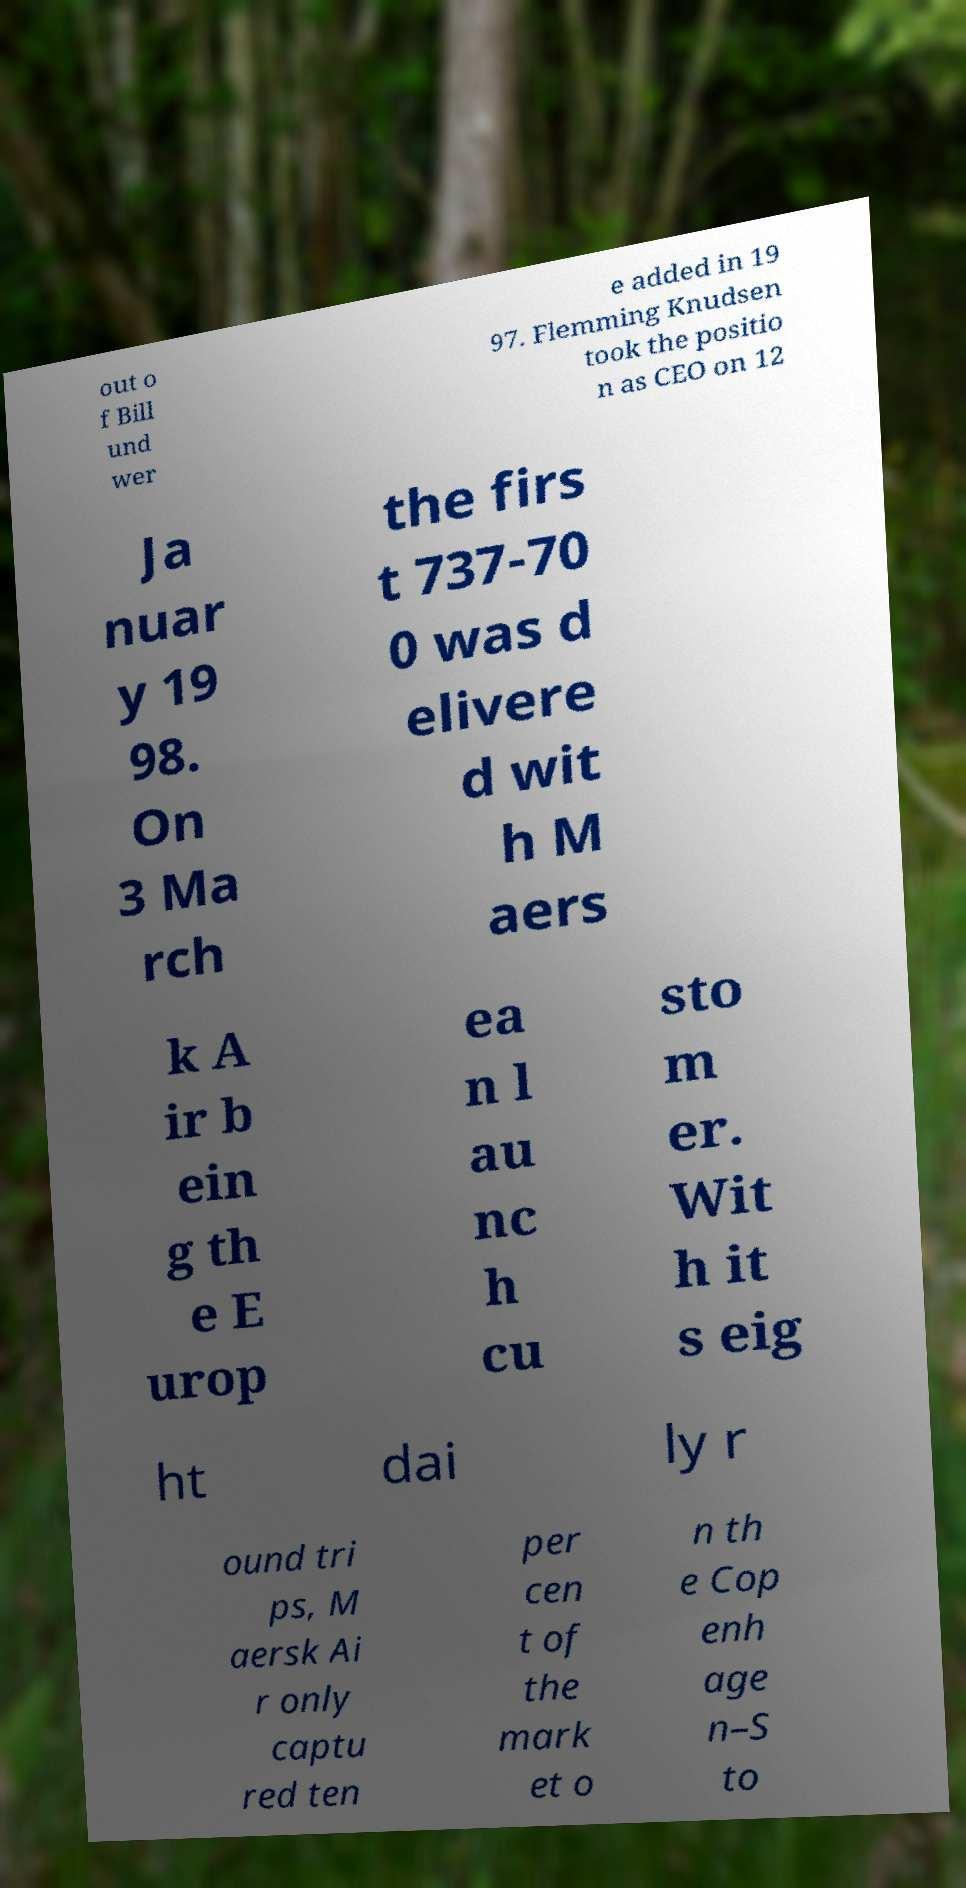For documentation purposes, I need the text within this image transcribed. Could you provide that? out o f Bill und wer e added in 19 97. Flemming Knudsen took the positio n as CEO on 12 Ja nuar y 19 98. On 3 Ma rch the firs t 737-70 0 was d elivere d wit h M aers k A ir b ein g th e E urop ea n l au nc h cu sto m er. Wit h it s eig ht dai ly r ound tri ps, M aersk Ai r only captu red ten per cen t of the mark et o n th e Cop enh age n–S to 